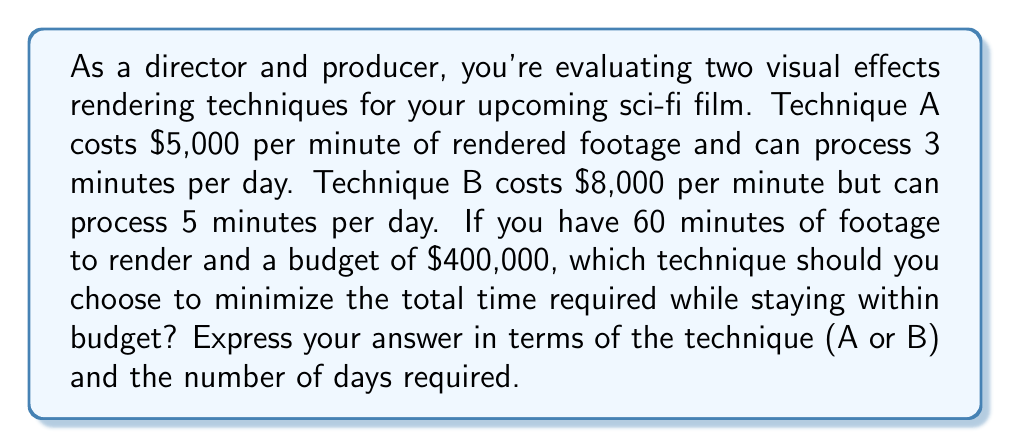Provide a solution to this math problem. Let's approach this step-by-step:

1) First, calculate the total cost for rendering 60 minutes of footage with each technique:

   Technique A: $5,000 * 60 = $300,000
   Technique B: $8,000 * 60 = $480,000

2) Technique B exceeds the budget, so we can immediately eliminate it as an option.

3) Now, let's calculate the time required for Technique A:

   $$\text{Time (in days)} = \frac{\text{Total minutes to render}}{\text{Minutes processed per day}}$$

   $$\text{Time for Technique A} = \frac{60 \text{ minutes}}{3 \text{ minutes/day}} = 20 \text{ days}$$

4) Although we've eliminated Technique B due to budget constraints, let's calculate its time for comparison:

   $$\text{Time for Technique B} = \frac{60 \text{ minutes}}{5 \text{ minutes/day}} = 12 \text{ days}$$

5) Technique A is the only option that fits within the budget constraint, and it requires 20 days to complete the rendering.
Answer: Technique A, 20 days 